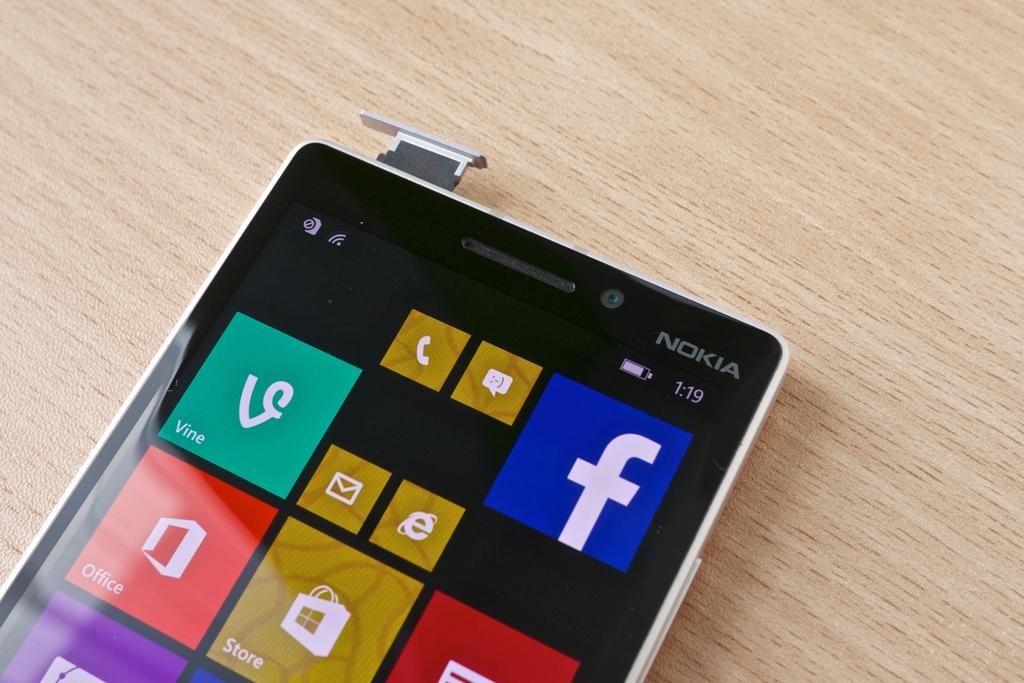<image>
Provide a brief description of the given image. a Nokia phone with the time of 1:19 on a table 